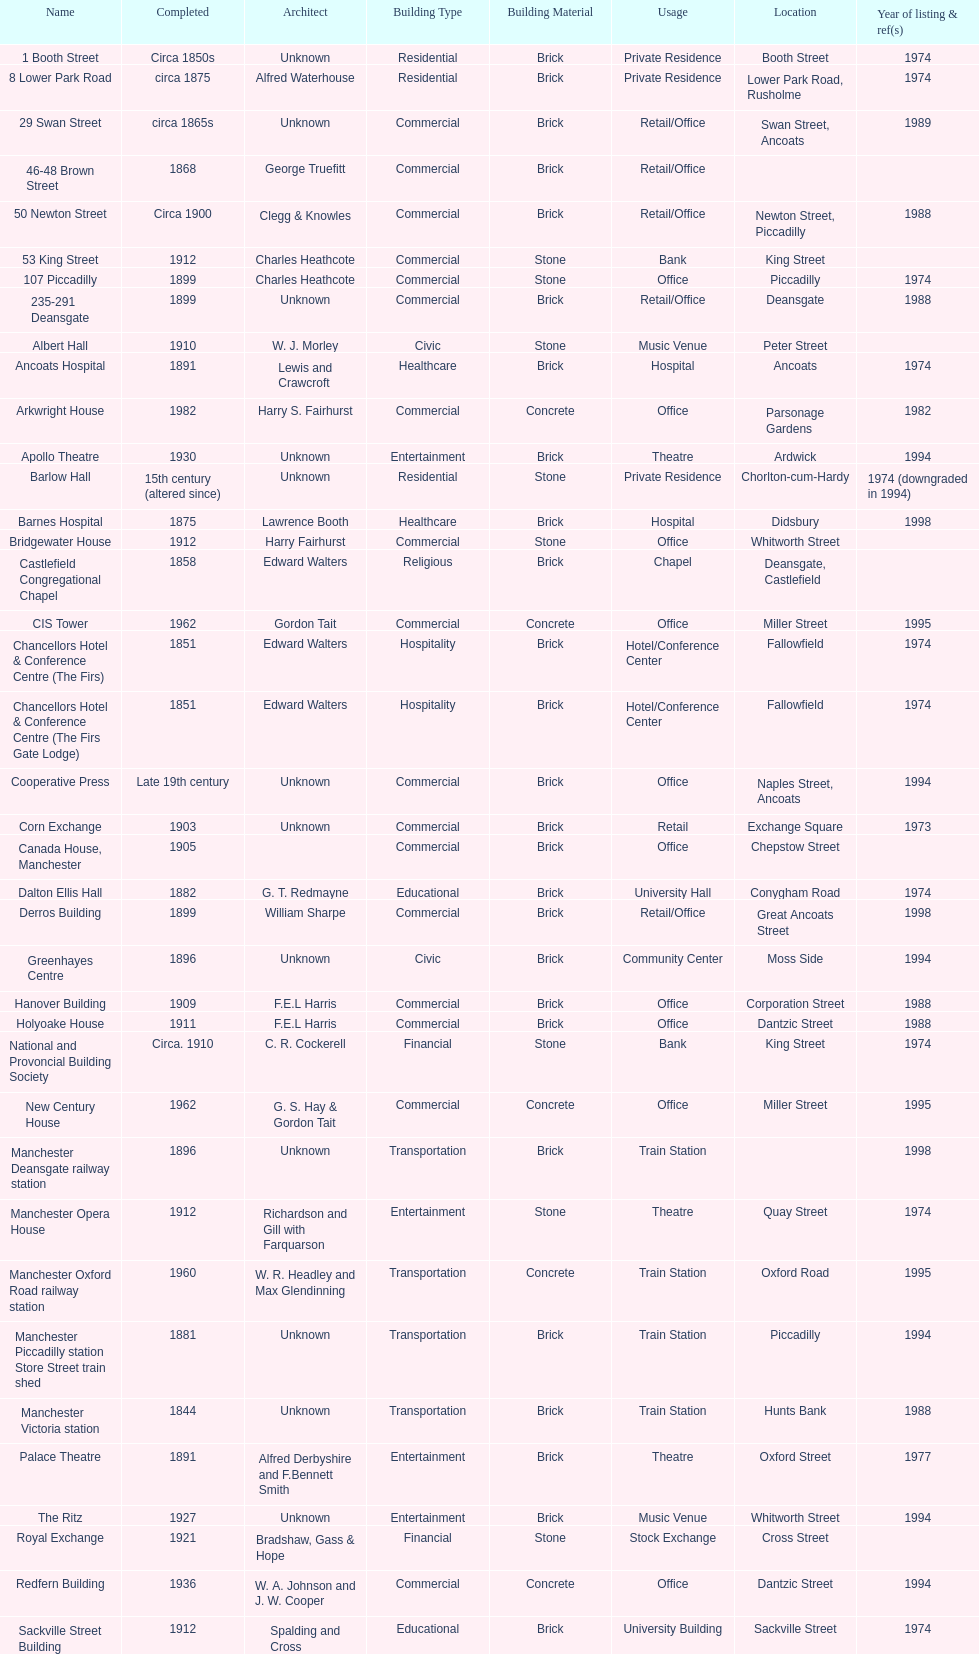How many buildings has the same year of listing as 1974? 15. 